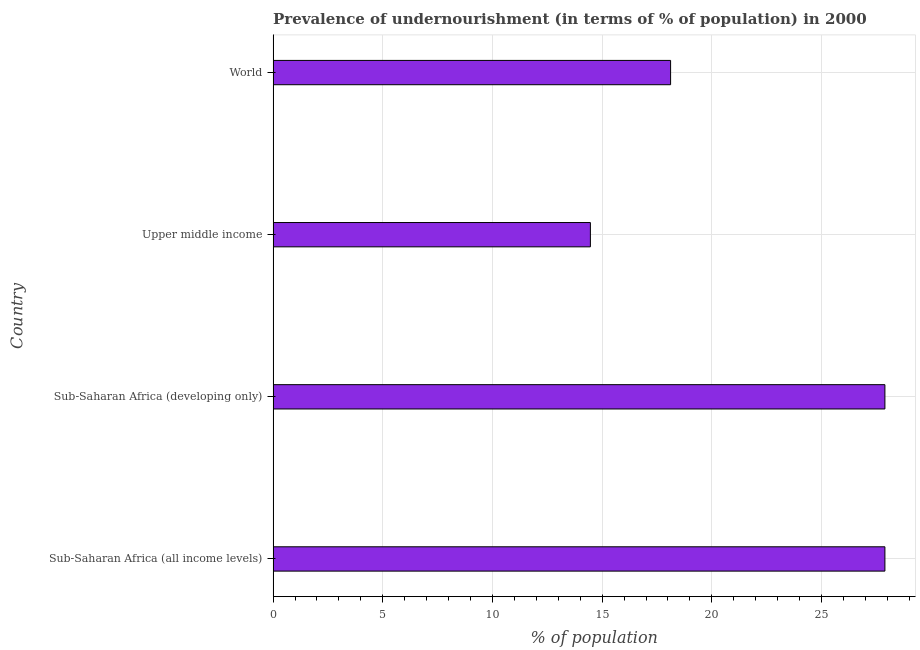Does the graph contain grids?
Ensure brevity in your answer.  Yes. What is the title of the graph?
Provide a succinct answer. Prevalence of undernourishment (in terms of % of population) in 2000. What is the label or title of the X-axis?
Give a very brief answer. % of population. What is the percentage of undernourished population in World?
Your response must be concise. 18.12. Across all countries, what is the maximum percentage of undernourished population?
Ensure brevity in your answer.  27.89. Across all countries, what is the minimum percentage of undernourished population?
Give a very brief answer. 14.46. In which country was the percentage of undernourished population maximum?
Your answer should be very brief. Sub-Saharan Africa (all income levels). In which country was the percentage of undernourished population minimum?
Offer a terse response. Upper middle income. What is the sum of the percentage of undernourished population?
Make the answer very short. 88.37. What is the difference between the percentage of undernourished population in Sub-Saharan Africa (developing only) and Upper middle income?
Make the answer very short. 13.43. What is the average percentage of undernourished population per country?
Offer a very short reply. 22.09. What is the median percentage of undernourished population?
Your response must be concise. 23.01. In how many countries, is the percentage of undernourished population greater than 24 %?
Your answer should be very brief. 2. What is the difference between the highest and the lowest percentage of undernourished population?
Provide a succinct answer. 13.43. Are the values on the major ticks of X-axis written in scientific E-notation?
Provide a short and direct response. No. What is the % of population in Sub-Saharan Africa (all income levels)?
Keep it short and to the point. 27.89. What is the % of population of Sub-Saharan Africa (developing only)?
Give a very brief answer. 27.89. What is the % of population in Upper middle income?
Your answer should be compact. 14.46. What is the % of population in World?
Keep it short and to the point. 18.12. What is the difference between the % of population in Sub-Saharan Africa (all income levels) and Upper middle income?
Offer a terse response. 13.43. What is the difference between the % of population in Sub-Saharan Africa (all income levels) and World?
Provide a succinct answer. 9.77. What is the difference between the % of population in Sub-Saharan Africa (developing only) and Upper middle income?
Ensure brevity in your answer.  13.43. What is the difference between the % of population in Sub-Saharan Africa (developing only) and World?
Your answer should be very brief. 9.77. What is the difference between the % of population in Upper middle income and World?
Make the answer very short. -3.66. What is the ratio of the % of population in Sub-Saharan Africa (all income levels) to that in Upper middle income?
Make the answer very short. 1.93. What is the ratio of the % of population in Sub-Saharan Africa (all income levels) to that in World?
Your answer should be very brief. 1.54. What is the ratio of the % of population in Sub-Saharan Africa (developing only) to that in Upper middle income?
Offer a terse response. 1.93. What is the ratio of the % of population in Sub-Saharan Africa (developing only) to that in World?
Ensure brevity in your answer.  1.54. What is the ratio of the % of population in Upper middle income to that in World?
Your response must be concise. 0.8. 